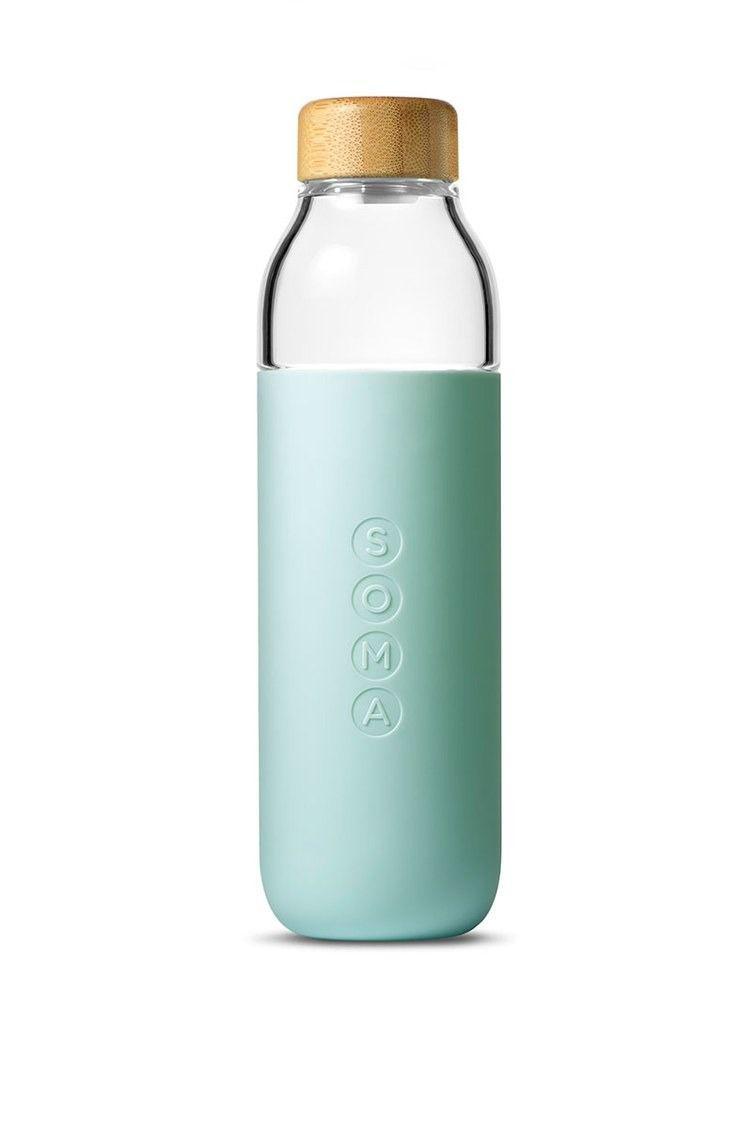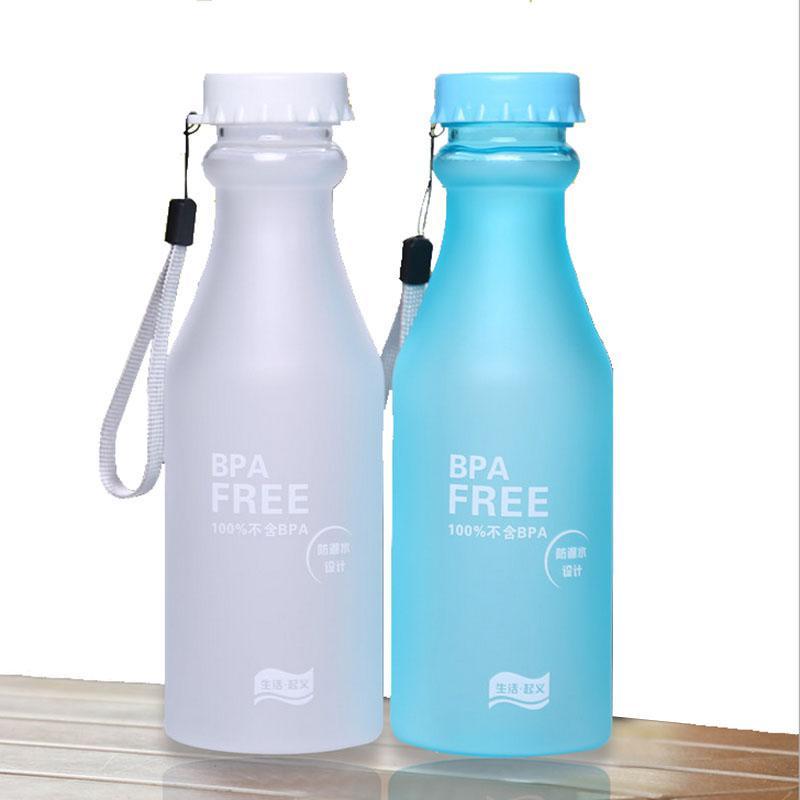The first image is the image on the left, the second image is the image on the right. For the images displayed, is the sentence "The left and right image contains the same number of water bottles with one being green and see through." factually correct? Answer yes or no. No. The first image is the image on the left, the second image is the image on the right. For the images displayed, is the sentence "At least one water bottle has a carrying strap hanging loosely down the side." factually correct? Answer yes or no. Yes. 